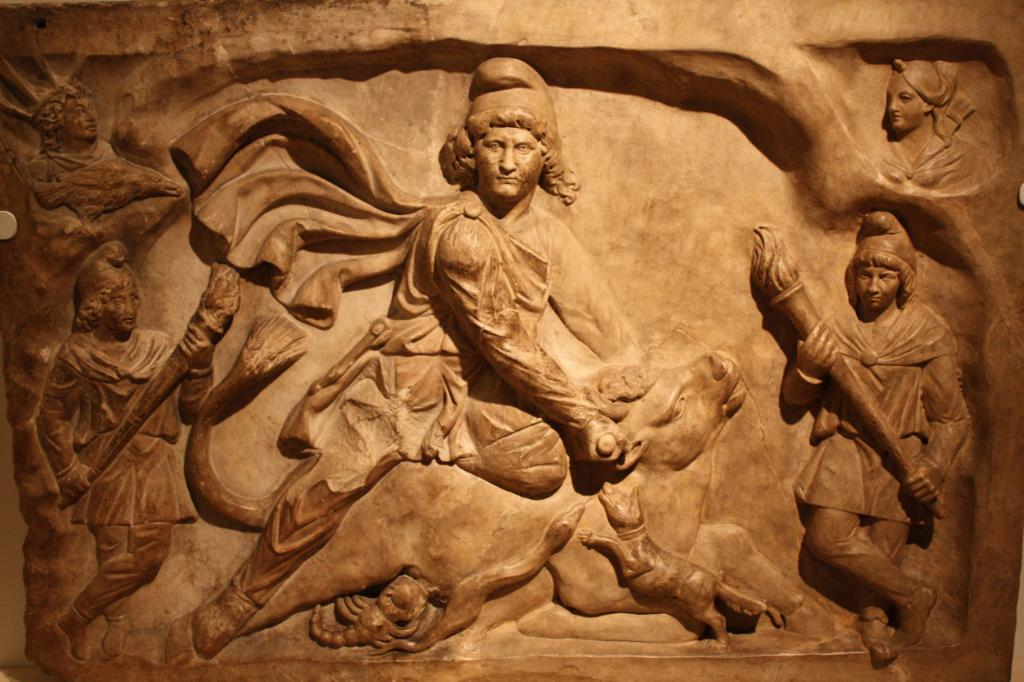What type of objects are depicted in the image? There are sculptures of people and an animal in the image. Can you describe the sculptures in more detail? Unfortunately, the provided facts do not give more specific details about the sculptures. What is the setting or location of the sculptures? The facts do not mention the setting or location of the sculptures. Can you describe the seashore in the image? There is no mention of a seashore in the image or the provided facts. 